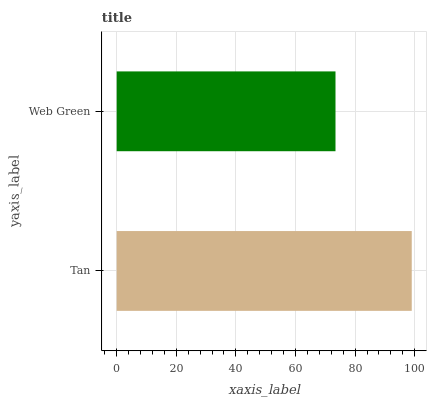Is Web Green the minimum?
Answer yes or no. Yes. Is Tan the maximum?
Answer yes or no. Yes. Is Web Green the maximum?
Answer yes or no. No. Is Tan greater than Web Green?
Answer yes or no. Yes. Is Web Green less than Tan?
Answer yes or no. Yes. Is Web Green greater than Tan?
Answer yes or no. No. Is Tan less than Web Green?
Answer yes or no. No. Is Tan the high median?
Answer yes or no. Yes. Is Web Green the low median?
Answer yes or no. Yes. Is Web Green the high median?
Answer yes or no. No. Is Tan the low median?
Answer yes or no. No. 